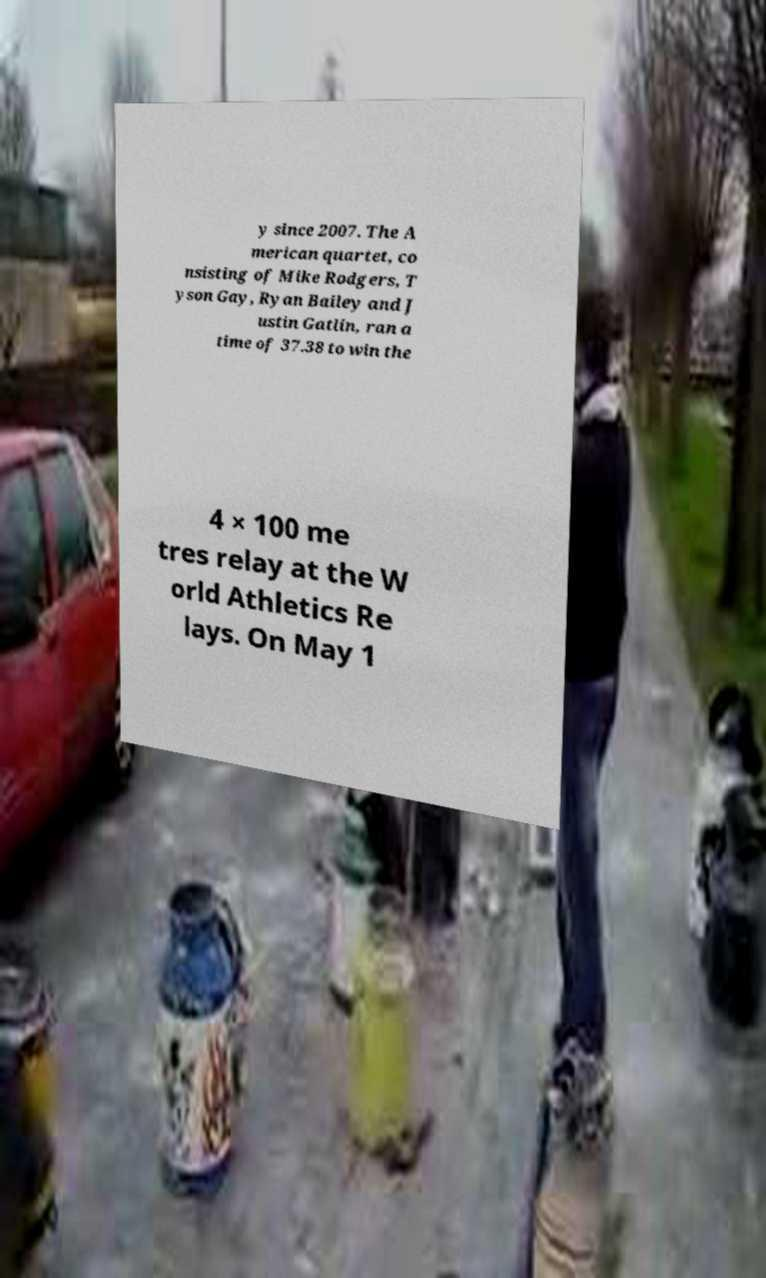For documentation purposes, I need the text within this image transcribed. Could you provide that? y since 2007. The A merican quartet, co nsisting of Mike Rodgers, T yson Gay, Ryan Bailey and J ustin Gatlin, ran a time of 37.38 to win the 4 × 100 me tres relay at the W orld Athletics Re lays. On May 1 